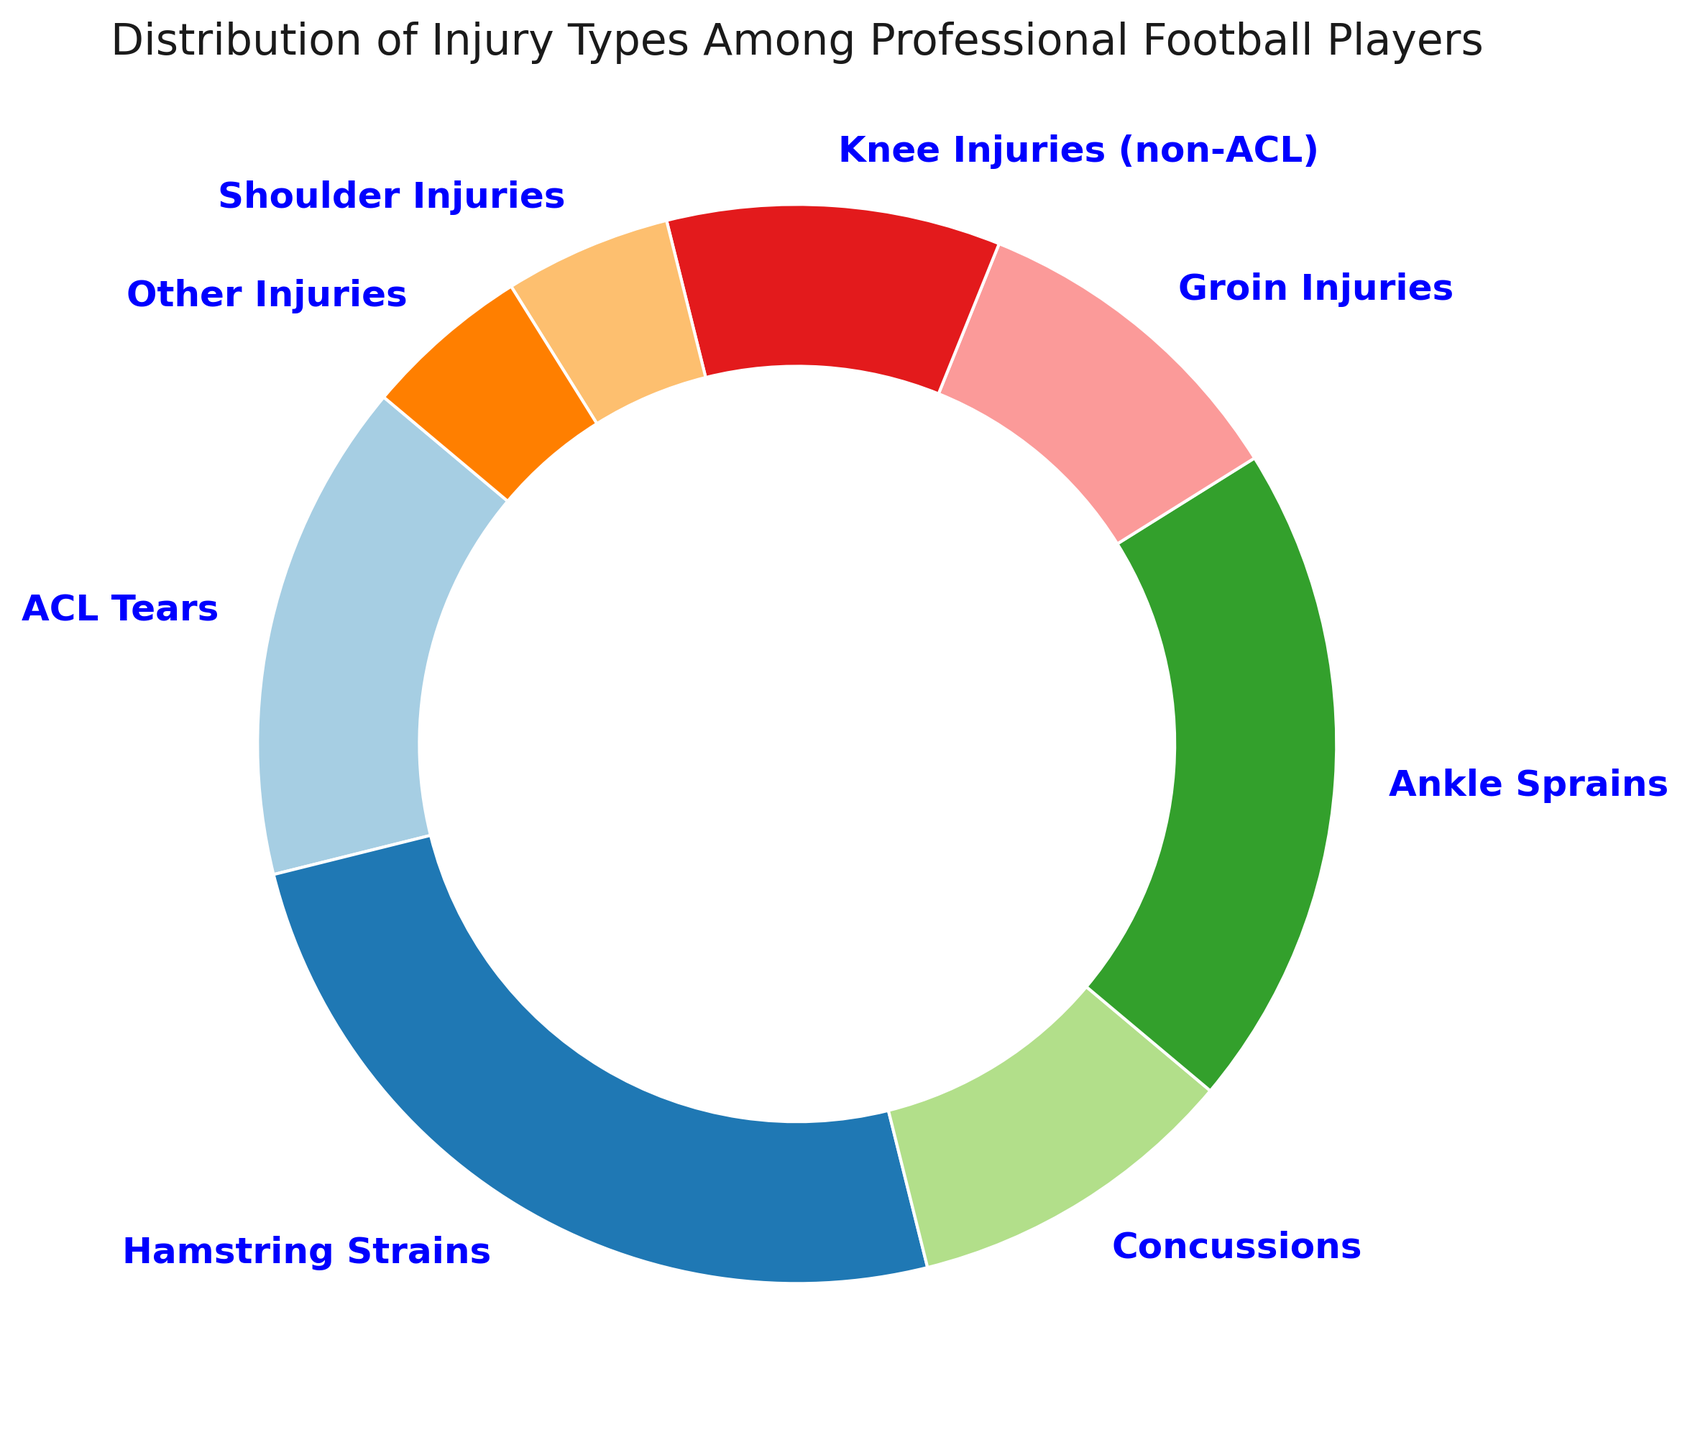Which injury type is the most common among professional football players? By looking at the pie chart, the injury type that occupies the largest slice is the most common. Hamstring Strains have the largest slice.
Answer: Hamstring Strains Which injury types have an equal distribution of occurrence? To answer this, look for slices of the pie that are the same size. Concussions, Groin Injuries, Knee Injuries (non-ACL), Shoulder Injuries, and Other Injuries each occupy 10% and 5% of the chart respectively.
Answer: Concussions, Groin Injuries, Knee Injuries (non-ACL) Which injury type has the second-highest percentage of occurrence? The second-largest slice on the pie chart indicates the second-highest percentage. Ankle Sprains are the second largest with 20%.
Answer: Ankle Sprains What's the combined percentage of ACL Tears and Shoulder Injuries? Add the percentages of ACL Tears and Shoulder Injuries found on the pie chart. ACL Tears are 15% and Shoulder Injuries are 5%. 15% + 5% = 20%.
Answer: 20% How does the percentage of Hamstring Strains compare to the percentage of ACL Tears? The slice for Hamstring Strains is larger than the slice for ACL Tears. Hamstring Strains are at 25%, which is 10% higher than ACL Tears at 15%.
Answer: Hamstring Strains are 10% higher Which injury type has the smallest contribution to the overall injuries? The smallest slice on the pie chart represents the least common injury type. Both Shoulder Injuries and Other Injuries have the smallest size at 5%.
Answer: Shoulder Injuries, Other Injuries What is the combined percentage of knee-related injuries (ACL Tears and Knee Injuries non-ACL)? Sum the percentages of ACL Tears and Knee Injuries (non-ACL). ACL Tears are 15% and Knee Injuries (non-ACL) are 10%. 15% + 10% = 25%.
Answer: 25% Among the injury types listed, which ones together account for half of all injuries? Find a combination of injury types that together sum to 50%. Hamstring Strains (25%) + Ankle Sprains (20%) + Shoulder Injuries (5%).
Answer: Hamstring Strains, Ankle Sprains, Shoulder Injuries How much more common are Hamstring Strains compared to Groin Injuries? Subtract the percentage of Groin Injuries from the percentage of Hamstring Strains. Hamstring Strains are 25% and Groin Injuries are 10%. 25% - 10% = 15%.
Answer: 15% Which injury types combined make up 70% of the injuries? Find a combination of the largest percentages that add up to 70%. Hamstring Strains (25%) + Ankle Sprains (20%) + ACL Tears (15%) + Concussions (10%).
Answer: Hamstring Strains, Ankle Sprains, ACL Tears, Concussions 